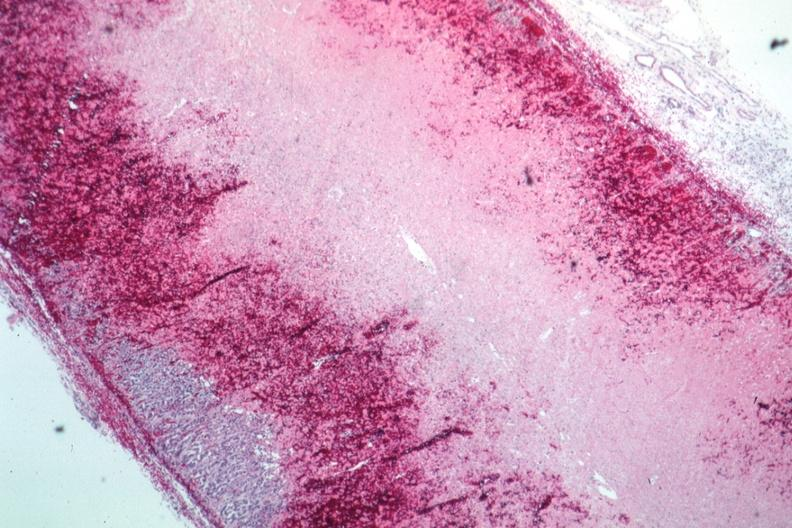what well shown?
Answer the question using a single word or phrase. Infarction and hemorrhage 